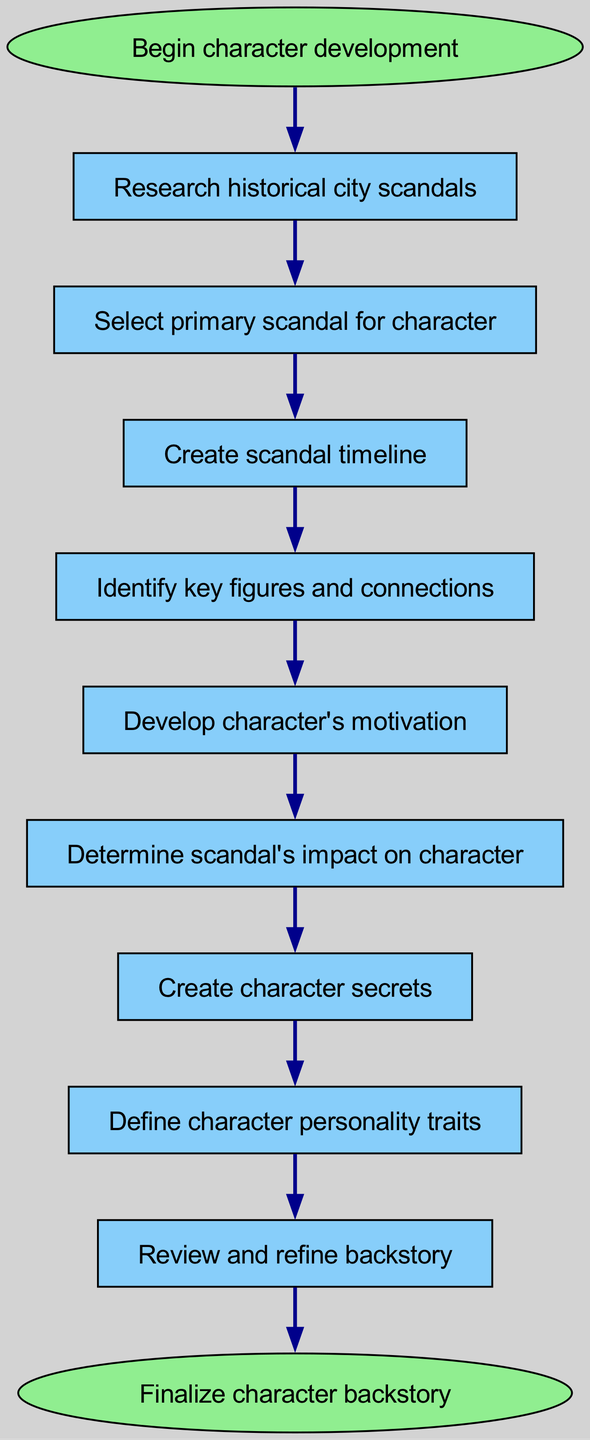What is the first step in the workflow? The first step is represented by the 'start' node, which indicates the beginning of character development.
Answer: Begin character development How many nodes are in the diagram? By counting each unique element within the 'elements' list of the data, we find that there are eleven nodes in total.
Answer: 11 What is the last step in the workflow? The last step is shown at the 'end' node, which signifies the finalization of the character backstory.
Answer: Finalize character backstory Which node directly follows 'Create scandal timeline'? The diagram indicates that 'Create scandal timeline' is connected to 'Identify key figures and connections', which is the next step in the workflow.
Answer: Identify key figures and connections Which element connects 'Determine scandal's impact on character' and 'Create character secrets'? There is a direct connection from 'Determine scandal's impact on character' to 'Create character secrets', indicating the flow of the process between these two nodes.
Answer: Create character secrets What is the relationship between 'Develop character's motivation' and 'Create character secrets'? 'Develop character's motivation' leads directly to 'Determine scandal's impact on character', and then to 'Create character secrets', showing that the latter is dependent on the former steps.
Answer: No direct connection What type of diagram is represented here? The diagram is a flow chart that outlines the steps taken in developing complex character backstories.
Answer: Flow chart What step occurs after 'Review and refine backstory'? According to the connections outlined in the diagram, the step that occurs after 'Review and refine backstory' is 'Finalize character backstory'.
Answer: Finalize character backstory How many connections are in the diagram? By counting the items in the 'connections' list, we see that there are ten connections linking the various steps in the workflow.
Answer: 10 